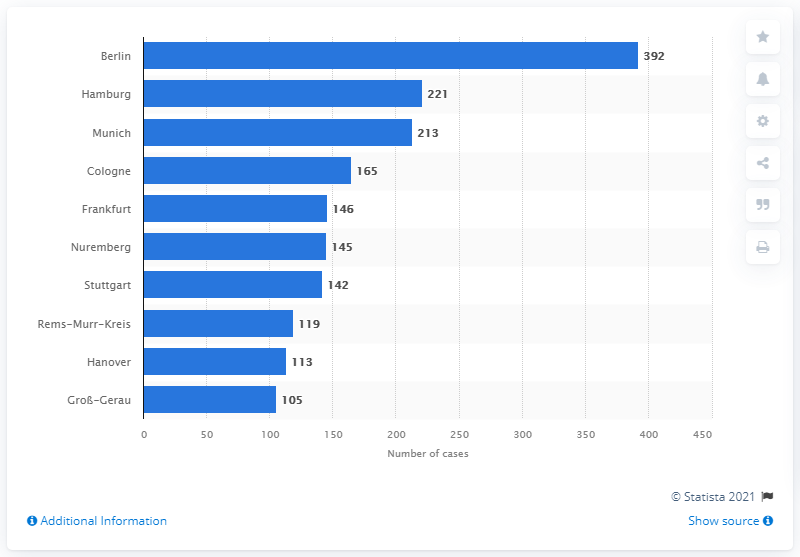Specify some key components in this picture. The average temperature between Berlin, Munich, and Frankfurt is approximately 250.3 degrees. Hamburg had the highest incidence rate of COVID-19 among all cities. According to data available by 2021, Berlin had the highest number of cases in Germany. 